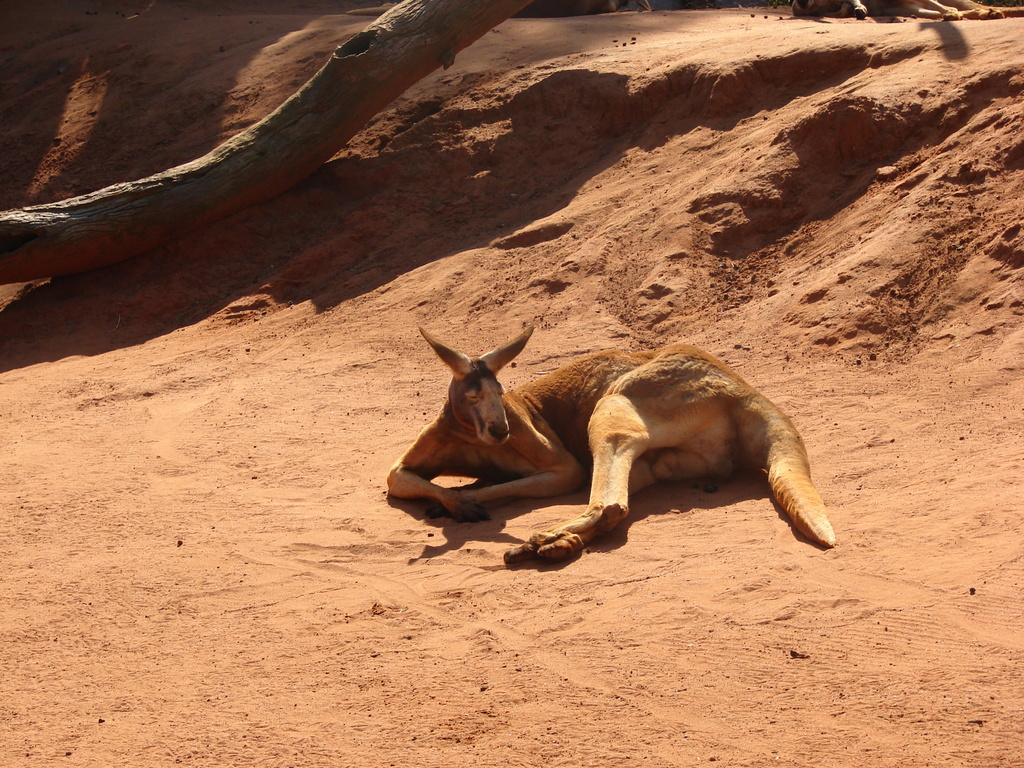What type of surface is visible in the image? There is sand in the image. What object can be seen in the image besides the sand? There is a tree branch in the image. What is the animal sitting on in the middle of the image? The animal is sitting on the sand in the middle of the image. What type of force is being applied to the wire in the image? There is no wire present in the image, so no force is being applied to a wire. 